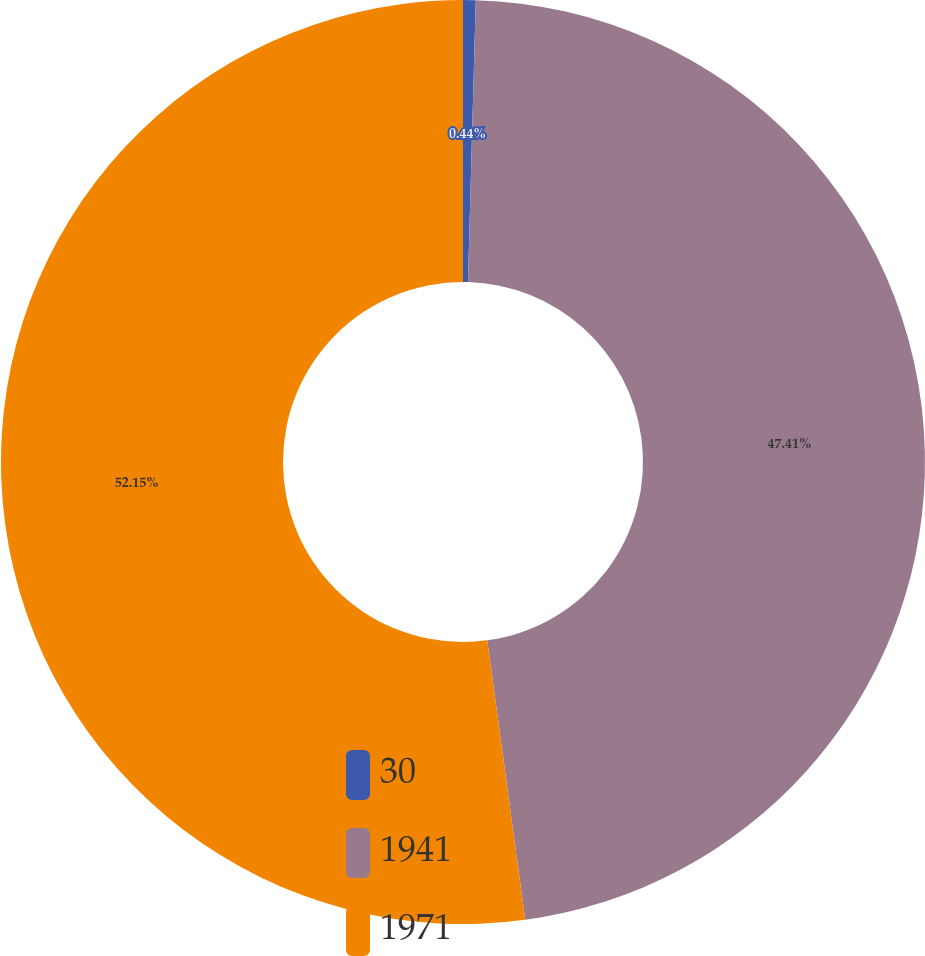Convert chart. <chart><loc_0><loc_0><loc_500><loc_500><pie_chart><fcel>30<fcel>1941<fcel>1971<nl><fcel>0.44%<fcel>47.41%<fcel>52.15%<nl></chart> 